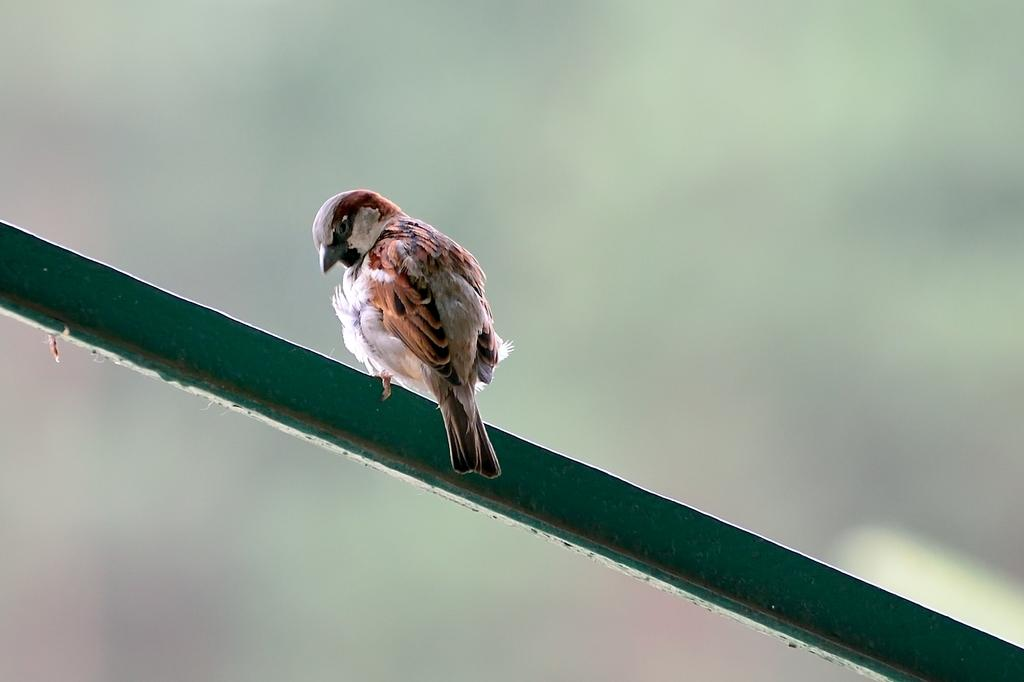What type of animal is in the image? There is a bird in the image. Can you describe the colors of the bird? The bird has cream, brown, and black colors. What is the bird sitting on in the image? The bird is on a green object. How would you describe the background of the image? The background of the image is blurry. How does the bird maintain its quietness while on the tray in the image? There is no tray present in the image, and the bird is not described as being quiet. 